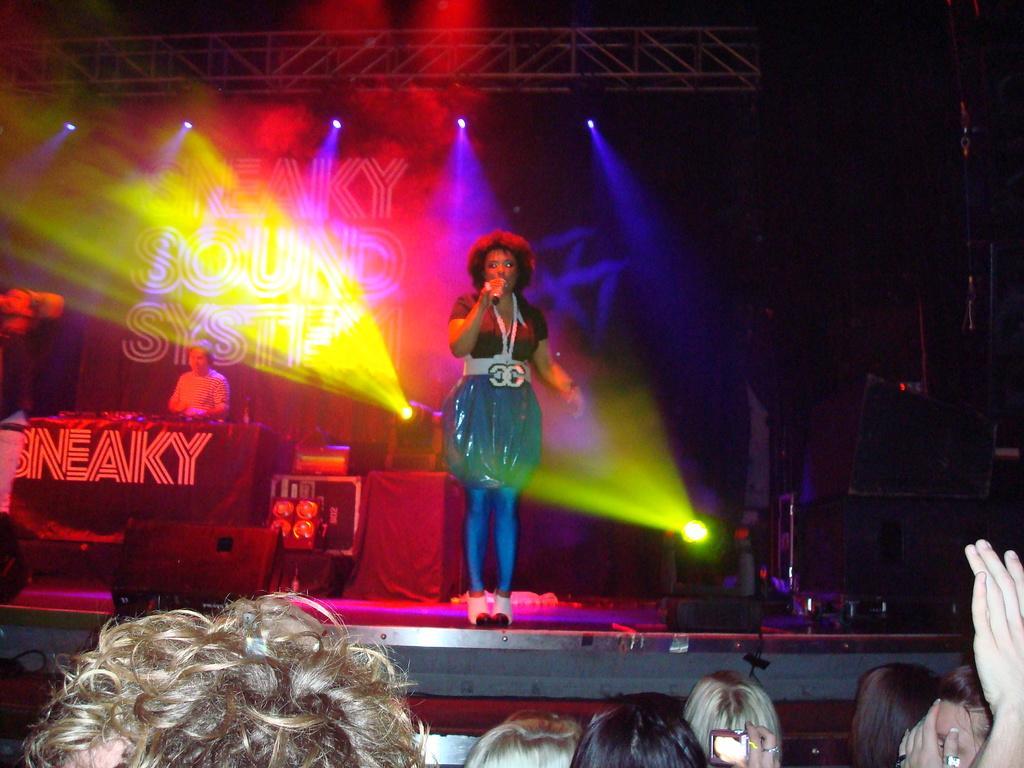In one or two sentences, can you explain what this image depicts? In the center of the image we can see a lady standing and holding a mic. At the bottom there are people and we can see lights. On the left there are two people on the dais. We can see speakers. At the top there are rods. 